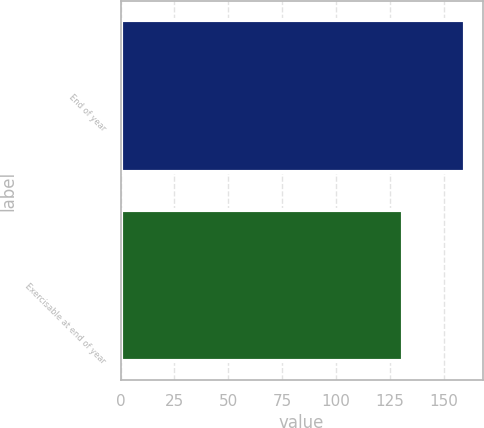<chart> <loc_0><loc_0><loc_500><loc_500><bar_chart><fcel>End of year<fcel>Exercisable at end of year<nl><fcel>160<fcel>131<nl></chart> 